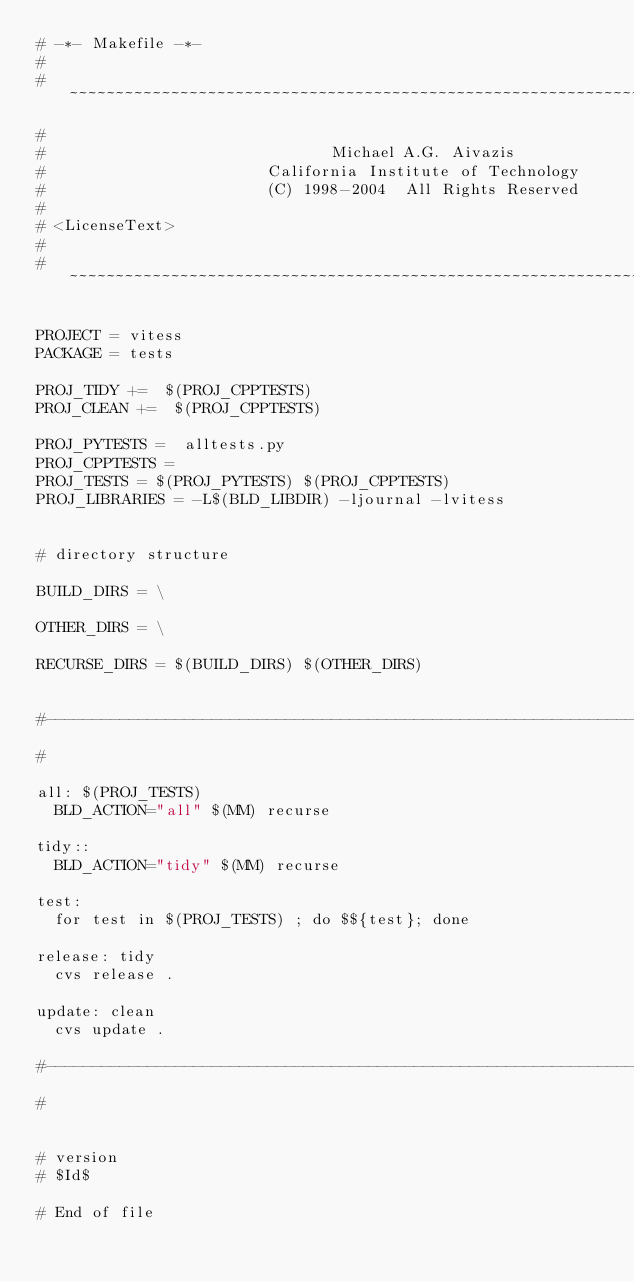Convert code to text. <code><loc_0><loc_0><loc_500><loc_500><_ObjectiveC_># -*- Makefile -*-
#
# ~~~~~~~~~~~~~~~~~~~~~~~~~~~~~~~~~~~~~~~~~~~~~~~~~~~~~~~~~~~~~~~~~~~~~~~~~~~~~~~~
#
#                               Michael A.G. Aivazis
#                        California Institute of Technology
#                        (C) 1998-2004  All Rights Reserved
#
# <LicenseText>
#
# ~~~~~~~~~~~~~~~~~~~~~~~~~~~~~~~~~~~~~~~~~~~~~~~~~~~~~~~~~~~~~~~~~~~~~~~~~~~~~~~~

PROJECT = vitess
PACKAGE = tests

PROJ_TIDY +=  $(PROJ_CPPTESTS)
PROJ_CLEAN +=  $(PROJ_CPPTESTS)

PROJ_PYTESTS =  alltests.py
PROJ_CPPTESTS = 
PROJ_TESTS = $(PROJ_PYTESTS) $(PROJ_CPPTESTS)
PROJ_LIBRARIES = -L$(BLD_LIBDIR) -ljournal -lvitess


# directory structure

BUILD_DIRS = \

OTHER_DIRS = \

RECURSE_DIRS = $(BUILD_DIRS) $(OTHER_DIRS)


#--------------------------------------------------------------------------
#

all: $(PROJ_TESTS)
	BLD_ACTION="all" $(MM) recurse

tidy::
	BLD_ACTION="tidy" $(MM) recurse

test: 
	for test in $(PROJ_TESTS) ; do $${test}; done

release: tidy
	cvs release .

update: clean
	cvs update .

#--------------------------------------------------------------------------
#


# version
# $Id$

# End of file
</code> 